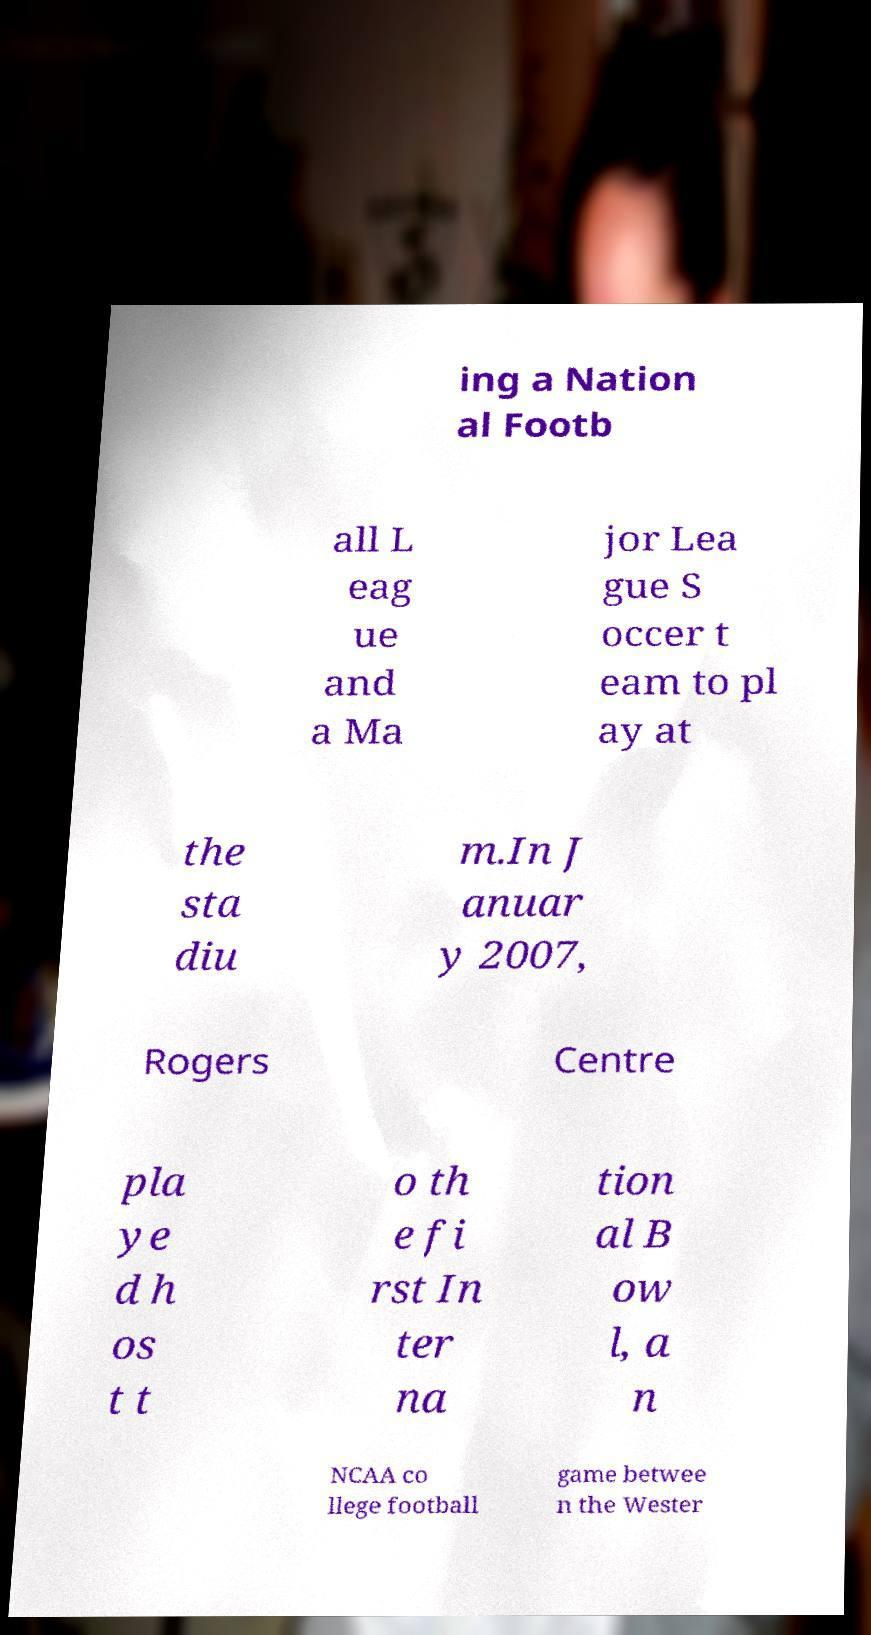Could you assist in decoding the text presented in this image and type it out clearly? ing a Nation al Footb all L eag ue and a Ma jor Lea gue S occer t eam to pl ay at the sta diu m.In J anuar y 2007, Rogers Centre pla ye d h os t t o th e fi rst In ter na tion al B ow l, a n NCAA co llege football game betwee n the Wester 